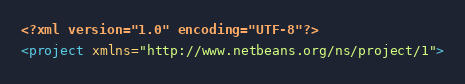<code> <loc_0><loc_0><loc_500><loc_500><_XML_><?xml version="1.0" encoding="UTF-8"?>
<project xmlns="http://www.netbeans.org/ns/project/1"></code> 